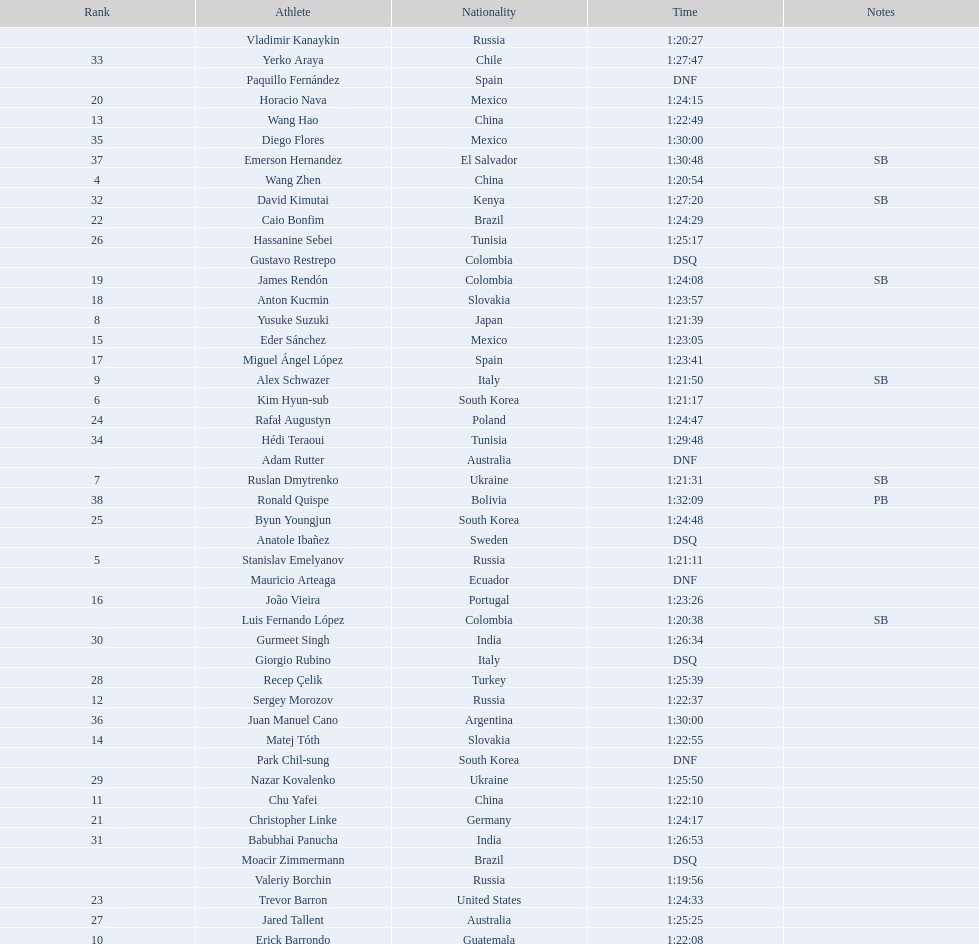How many competitors were from russia? 4. Could you parse the entire table? {'header': ['Rank', 'Athlete', 'Nationality', 'Time', 'Notes'], 'rows': [['', 'Vladimir Kanaykin', 'Russia', '1:20:27', ''], ['33', 'Yerko Araya', 'Chile', '1:27:47', ''], ['', 'Paquillo Fernández', 'Spain', 'DNF', ''], ['20', 'Horacio Nava', 'Mexico', '1:24:15', ''], ['13', 'Wang Hao', 'China', '1:22:49', ''], ['35', 'Diego Flores', 'Mexico', '1:30:00', ''], ['37', 'Emerson Hernandez', 'El Salvador', '1:30:48', 'SB'], ['4', 'Wang Zhen', 'China', '1:20:54', ''], ['32', 'David Kimutai', 'Kenya', '1:27:20', 'SB'], ['22', 'Caio Bonfim', 'Brazil', '1:24:29', ''], ['26', 'Hassanine Sebei', 'Tunisia', '1:25:17', ''], ['', 'Gustavo Restrepo', 'Colombia', 'DSQ', ''], ['19', 'James Rendón', 'Colombia', '1:24:08', 'SB'], ['18', 'Anton Kucmin', 'Slovakia', '1:23:57', ''], ['8', 'Yusuke Suzuki', 'Japan', '1:21:39', ''], ['15', 'Eder Sánchez', 'Mexico', '1:23:05', ''], ['17', 'Miguel Ángel López', 'Spain', '1:23:41', ''], ['9', 'Alex Schwazer', 'Italy', '1:21:50', 'SB'], ['6', 'Kim Hyun-sub', 'South Korea', '1:21:17', ''], ['24', 'Rafał Augustyn', 'Poland', '1:24:47', ''], ['34', 'Hédi Teraoui', 'Tunisia', '1:29:48', ''], ['', 'Adam Rutter', 'Australia', 'DNF', ''], ['7', 'Ruslan Dmytrenko', 'Ukraine', '1:21:31', 'SB'], ['38', 'Ronald Quispe', 'Bolivia', '1:32:09', 'PB'], ['25', 'Byun Youngjun', 'South Korea', '1:24:48', ''], ['', 'Anatole Ibañez', 'Sweden', 'DSQ', ''], ['5', 'Stanislav Emelyanov', 'Russia', '1:21:11', ''], ['', 'Mauricio Arteaga', 'Ecuador', 'DNF', ''], ['16', 'João Vieira', 'Portugal', '1:23:26', ''], ['', 'Luis Fernando López', 'Colombia', '1:20:38', 'SB'], ['30', 'Gurmeet Singh', 'India', '1:26:34', ''], ['', 'Giorgio Rubino', 'Italy', 'DSQ', ''], ['28', 'Recep Çelik', 'Turkey', '1:25:39', ''], ['12', 'Sergey Morozov', 'Russia', '1:22:37', ''], ['36', 'Juan Manuel Cano', 'Argentina', '1:30:00', ''], ['14', 'Matej Tóth', 'Slovakia', '1:22:55', ''], ['', 'Park Chil-sung', 'South Korea', 'DNF', ''], ['29', 'Nazar Kovalenko', 'Ukraine', '1:25:50', ''], ['11', 'Chu Yafei', 'China', '1:22:10', ''], ['21', 'Christopher Linke', 'Germany', '1:24:17', ''], ['31', 'Babubhai Panucha', 'India', '1:26:53', ''], ['', 'Moacir Zimmermann', 'Brazil', 'DSQ', ''], ['', 'Valeriy Borchin', 'Russia', '1:19:56', ''], ['23', 'Trevor Barron', 'United States', '1:24:33', ''], ['27', 'Jared Tallent', 'Australia', '1:25:25', ''], ['10', 'Erick Barrondo', 'Guatemala', '1:22:08', '']]} 